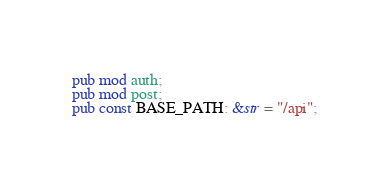Convert code to text. <code><loc_0><loc_0><loc_500><loc_500><_Rust_>pub mod auth;
pub mod post;
pub const BASE_PATH: &str = "/api";
</code> 